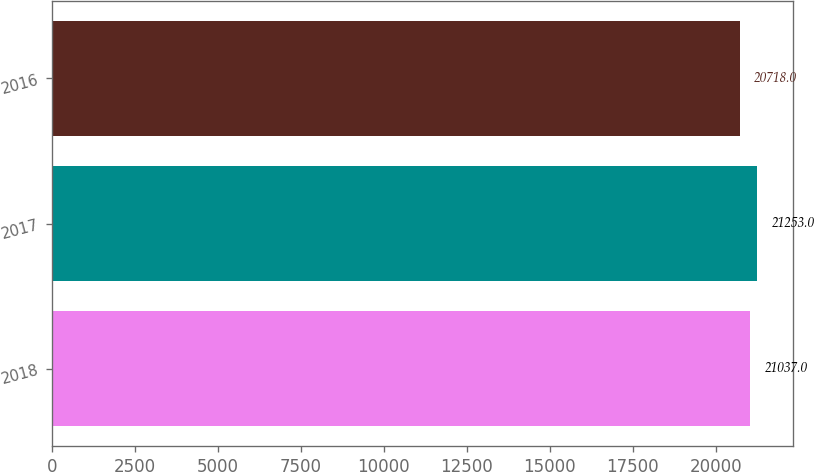<chart> <loc_0><loc_0><loc_500><loc_500><bar_chart><fcel>2018<fcel>2017<fcel>2016<nl><fcel>21037<fcel>21253<fcel>20718<nl></chart> 